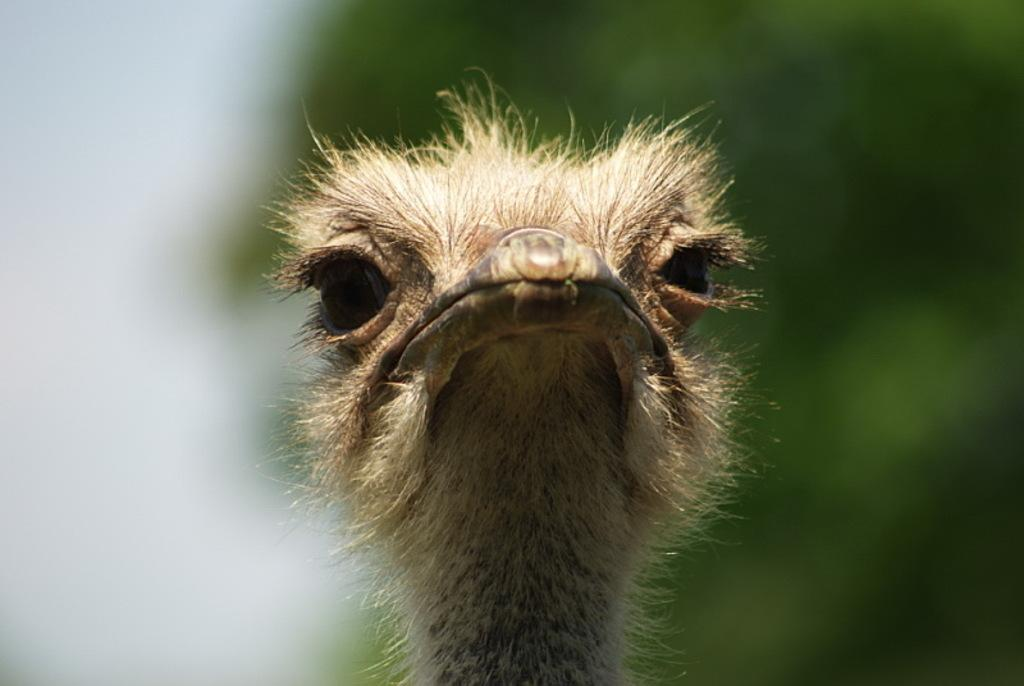What type of animal is featured in the image? The image contains the head of a bird. Can you describe the background of the image? The background of the image is blurry. How many apples are being held by the horse in the image? There is no horse or apples present in the image; it features the head of a bird. What type of bean is visible in the image? There is no bean present in the image. 